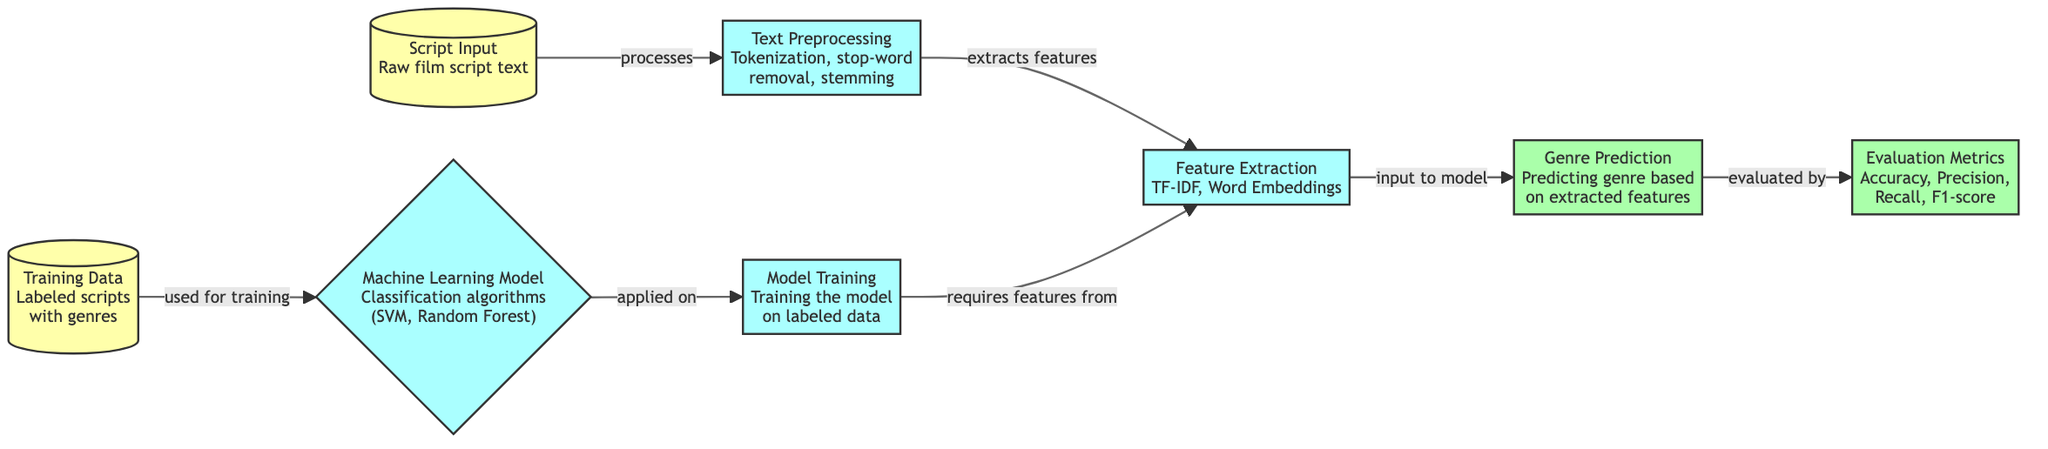What is the first step in the process? The diagram indicates that the first step is "Script Input," which involves receiving the raw film script text.
Answer: Script Input How many main processes are depicted in the diagram? The diagram shows four main processes: Text Preprocessing, Feature Extraction, Machine Learning Model, and Model Training.
Answer: Four What type of algorithms are used in the model? According to the diagram, the classification algorithms used in the model include SVM and Random Forest.
Answer: SVM, Random Forest Which node directly follows "Feature Extraction"? The node that comes directly after "Feature Extraction" is "Genre Prediction," indicating the output of the extracted features.
Answer: Genre Prediction What do Evaluation Metrics measure? The Evaluation Metrics node measures Accuracy, Precision, Recall, and F1-score, which are key performance indicators for the model.
Answer: Accuracy, Precision, Recall, F1-score What is the relationship between Model Training and Training Data? The arrow indicates that Model Training requires Training Data, which consists of labeled scripts with genres to learn from.
Answer: Used for training Which node produces the final output of the process? The final output of the process is produced by the "Genre Prediction" node, which predicts the genre based on the extracted features.
Answer: Genre Prediction What is required for Model Training to proceed? Model Training requires features extracted from the previous step, Feature Extraction, as its input to function properly.
Answer: Features from Feature Extraction How are the output metrics evaluated according to the diagram? The diagram indicates that the output from Genre Prediction is evaluated by the Evaluation Metrics, showcasing the performance of the predictions.
Answer: Evaluated by 